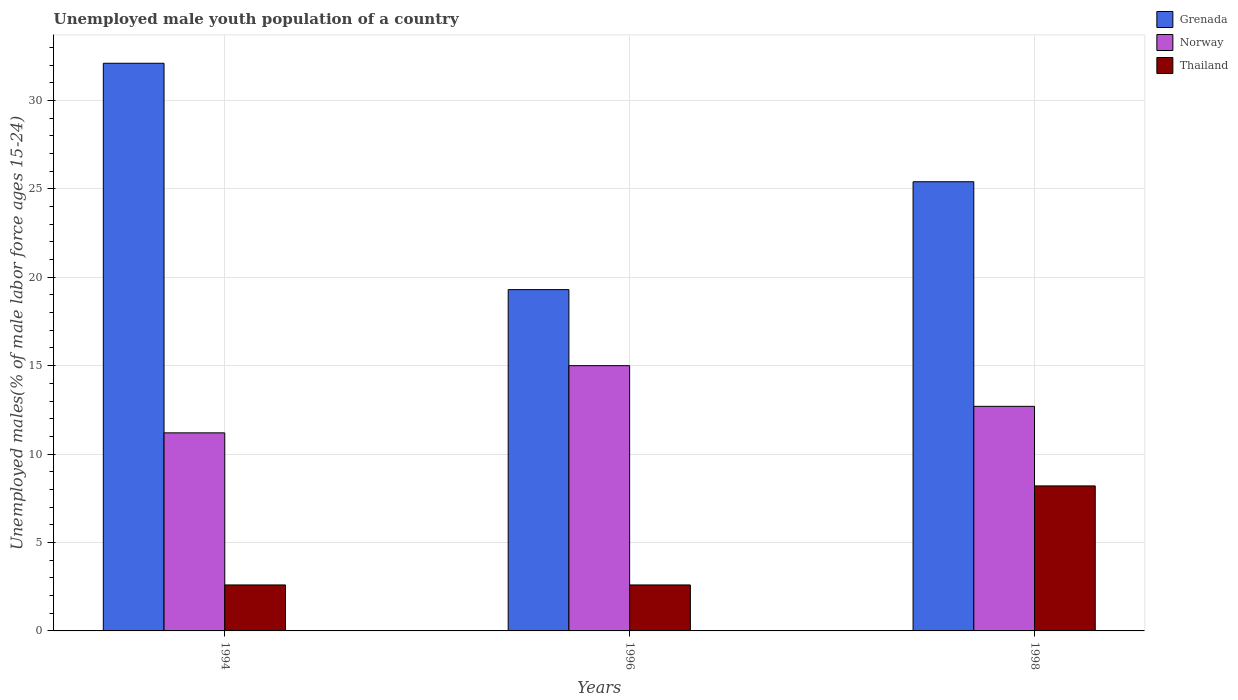How many groups of bars are there?
Keep it short and to the point. 3. Are the number of bars per tick equal to the number of legend labels?
Give a very brief answer. Yes. Are the number of bars on each tick of the X-axis equal?
Offer a very short reply. Yes. How many bars are there on the 3rd tick from the left?
Give a very brief answer. 3. In how many cases, is the number of bars for a given year not equal to the number of legend labels?
Your response must be concise. 0. What is the percentage of unemployed male youth population in Thailand in 1998?
Provide a short and direct response. 8.2. Across all years, what is the maximum percentage of unemployed male youth population in Thailand?
Give a very brief answer. 8.2. Across all years, what is the minimum percentage of unemployed male youth population in Grenada?
Your answer should be compact. 19.3. In which year was the percentage of unemployed male youth population in Thailand maximum?
Make the answer very short. 1998. What is the total percentage of unemployed male youth population in Norway in the graph?
Your response must be concise. 38.9. What is the difference between the percentage of unemployed male youth population in Norway in 1994 and that in 1996?
Keep it short and to the point. -3.8. What is the difference between the percentage of unemployed male youth population in Norway in 1998 and the percentage of unemployed male youth population in Thailand in 1994?
Give a very brief answer. 10.1. What is the average percentage of unemployed male youth population in Norway per year?
Give a very brief answer. 12.97. In the year 1996, what is the difference between the percentage of unemployed male youth population in Norway and percentage of unemployed male youth population in Grenada?
Your answer should be very brief. -4.3. What is the ratio of the percentage of unemployed male youth population in Thailand in 1996 to that in 1998?
Keep it short and to the point. 0.32. Is the difference between the percentage of unemployed male youth population in Norway in 1994 and 1998 greater than the difference between the percentage of unemployed male youth population in Grenada in 1994 and 1998?
Provide a succinct answer. No. What is the difference between the highest and the second highest percentage of unemployed male youth population in Grenada?
Give a very brief answer. 6.7. What is the difference between the highest and the lowest percentage of unemployed male youth population in Norway?
Offer a very short reply. 3.8. What does the 3rd bar from the left in 1996 represents?
Ensure brevity in your answer.  Thailand. What does the 3rd bar from the right in 1996 represents?
Give a very brief answer. Grenada. Is it the case that in every year, the sum of the percentage of unemployed male youth population in Grenada and percentage of unemployed male youth population in Thailand is greater than the percentage of unemployed male youth population in Norway?
Provide a short and direct response. Yes. Are all the bars in the graph horizontal?
Make the answer very short. No. How many years are there in the graph?
Your answer should be very brief. 3. Does the graph contain any zero values?
Keep it short and to the point. No. How are the legend labels stacked?
Your answer should be compact. Vertical. What is the title of the graph?
Provide a short and direct response. Unemployed male youth population of a country. What is the label or title of the X-axis?
Make the answer very short. Years. What is the label or title of the Y-axis?
Provide a short and direct response. Unemployed males(% of male labor force ages 15-24). What is the Unemployed males(% of male labor force ages 15-24) in Grenada in 1994?
Your answer should be very brief. 32.1. What is the Unemployed males(% of male labor force ages 15-24) in Norway in 1994?
Provide a succinct answer. 11.2. What is the Unemployed males(% of male labor force ages 15-24) of Thailand in 1994?
Provide a short and direct response. 2.6. What is the Unemployed males(% of male labor force ages 15-24) of Grenada in 1996?
Provide a short and direct response. 19.3. What is the Unemployed males(% of male labor force ages 15-24) in Thailand in 1996?
Your answer should be very brief. 2.6. What is the Unemployed males(% of male labor force ages 15-24) in Grenada in 1998?
Offer a very short reply. 25.4. What is the Unemployed males(% of male labor force ages 15-24) in Norway in 1998?
Give a very brief answer. 12.7. What is the Unemployed males(% of male labor force ages 15-24) of Thailand in 1998?
Your answer should be compact. 8.2. Across all years, what is the maximum Unemployed males(% of male labor force ages 15-24) of Grenada?
Provide a short and direct response. 32.1. Across all years, what is the maximum Unemployed males(% of male labor force ages 15-24) of Norway?
Offer a very short reply. 15. Across all years, what is the maximum Unemployed males(% of male labor force ages 15-24) of Thailand?
Provide a short and direct response. 8.2. Across all years, what is the minimum Unemployed males(% of male labor force ages 15-24) of Grenada?
Make the answer very short. 19.3. Across all years, what is the minimum Unemployed males(% of male labor force ages 15-24) in Norway?
Offer a terse response. 11.2. Across all years, what is the minimum Unemployed males(% of male labor force ages 15-24) of Thailand?
Offer a very short reply. 2.6. What is the total Unemployed males(% of male labor force ages 15-24) in Grenada in the graph?
Provide a succinct answer. 76.8. What is the total Unemployed males(% of male labor force ages 15-24) of Norway in the graph?
Ensure brevity in your answer.  38.9. What is the total Unemployed males(% of male labor force ages 15-24) in Thailand in the graph?
Your answer should be compact. 13.4. What is the difference between the Unemployed males(% of male labor force ages 15-24) of Norway in 1994 and that in 1996?
Offer a terse response. -3.8. What is the difference between the Unemployed males(% of male labor force ages 15-24) in Norway in 1994 and that in 1998?
Provide a short and direct response. -1.5. What is the difference between the Unemployed males(% of male labor force ages 15-24) of Norway in 1996 and that in 1998?
Provide a succinct answer. 2.3. What is the difference between the Unemployed males(% of male labor force ages 15-24) in Thailand in 1996 and that in 1998?
Give a very brief answer. -5.6. What is the difference between the Unemployed males(% of male labor force ages 15-24) of Grenada in 1994 and the Unemployed males(% of male labor force ages 15-24) of Norway in 1996?
Your answer should be very brief. 17.1. What is the difference between the Unemployed males(% of male labor force ages 15-24) in Grenada in 1994 and the Unemployed males(% of male labor force ages 15-24) in Thailand in 1996?
Your answer should be compact. 29.5. What is the difference between the Unemployed males(% of male labor force ages 15-24) in Norway in 1994 and the Unemployed males(% of male labor force ages 15-24) in Thailand in 1996?
Give a very brief answer. 8.6. What is the difference between the Unemployed males(% of male labor force ages 15-24) of Grenada in 1994 and the Unemployed males(% of male labor force ages 15-24) of Norway in 1998?
Your response must be concise. 19.4. What is the difference between the Unemployed males(% of male labor force ages 15-24) of Grenada in 1994 and the Unemployed males(% of male labor force ages 15-24) of Thailand in 1998?
Your answer should be very brief. 23.9. What is the difference between the Unemployed males(% of male labor force ages 15-24) of Norway in 1994 and the Unemployed males(% of male labor force ages 15-24) of Thailand in 1998?
Your answer should be very brief. 3. What is the difference between the Unemployed males(% of male labor force ages 15-24) of Grenada in 1996 and the Unemployed males(% of male labor force ages 15-24) of Thailand in 1998?
Provide a succinct answer. 11.1. What is the average Unemployed males(% of male labor force ages 15-24) in Grenada per year?
Ensure brevity in your answer.  25.6. What is the average Unemployed males(% of male labor force ages 15-24) in Norway per year?
Offer a very short reply. 12.97. What is the average Unemployed males(% of male labor force ages 15-24) of Thailand per year?
Provide a short and direct response. 4.47. In the year 1994, what is the difference between the Unemployed males(% of male labor force ages 15-24) in Grenada and Unemployed males(% of male labor force ages 15-24) in Norway?
Provide a short and direct response. 20.9. In the year 1994, what is the difference between the Unemployed males(% of male labor force ages 15-24) of Grenada and Unemployed males(% of male labor force ages 15-24) of Thailand?
Keep it short and to the point. 29.5. In the year 1996, what is the difference between the Unemployed males(% of male labor force ages 15-24) in Grenada and Unemployed males(% of male labor force ages 15-24) in Norway?
Your answer should be compact. 4.3. In the year 1996, what is the difference between the Unemployed males(% of male labor force ages 15-24) in Grenada and Unemployed males(% of male labor force ages 15-24) in Thailand?
Ensure brevity in your answer.  16.7. In the year 1998, what is the difference between the Unemployed males(% of male labor force ages 15-24) of Grenada and Unemployed males(% of male labor force ages 15-24) of Thailand?
Provide a succinct answer. 17.2. In the year 1998, what is the difference between the Unemployed males(% of male labor force ages 15-24) in Norway and Unemployed males(% of male labor force ages 15-24) in Thailand?
Your answer should be compact. 4.5. What is the ratio of the Unemployed males(% of male labor force ages 15-24) of Grenada in 1994 to that in 1996?
Make the answer very short. 1.66. What is the ratio of the Unemployed males(% of male labor force ages 15-24) of Norway in 1994 to that in 1996?
Offer a very short reply. 0.75. What is the ratio of the Unemployed males(% of male labor force ages 15-24) in Grenada in 1994 to that in 1998?
Offer a terse response. 1.26. What is the ratio of the Unemployed males(% of male labor force ages 15-24) in Norway in 1994 to that in 1998?
Your answer should be compact. 0.88. What is the ratio of the Unemployed males(% of male labor force ages 15-24) of Thailand in 1994 to that in 1998?
Provide a succinct answer. 0.32. What is the ratio of the Unemployed males(% of male labor force ages 15-24) of Grenada in 1996 to that in 1998?
Offer a terse response. 0.76. What is the ratio of the Unemployed males(% of male labor force ages 15-24) of Norway in 1996 to that in 1998?
Provide a short and direct response. 1.18. What is the ratio of the Unemployed males(% of male labor force ages 15-24) in Thailand in 1996 to that in 1998?
Your answer should be very brief. 0.32. What is the difference between the highest and the lowest Unemployed males(% of male labor force ages 15-24) of Grenada?
Offer a very short reply. 12.8. What is the difference between the highest and the lowest Unemployed males(% of male labor force ages 15-24) in Norway?
Your answer should be very brief. 3.8. What is the difference between the highest and the lowest Unemployed males(% of male labor force ages 15-24) of Thailand?
Your answer should be compact. 5.6. 